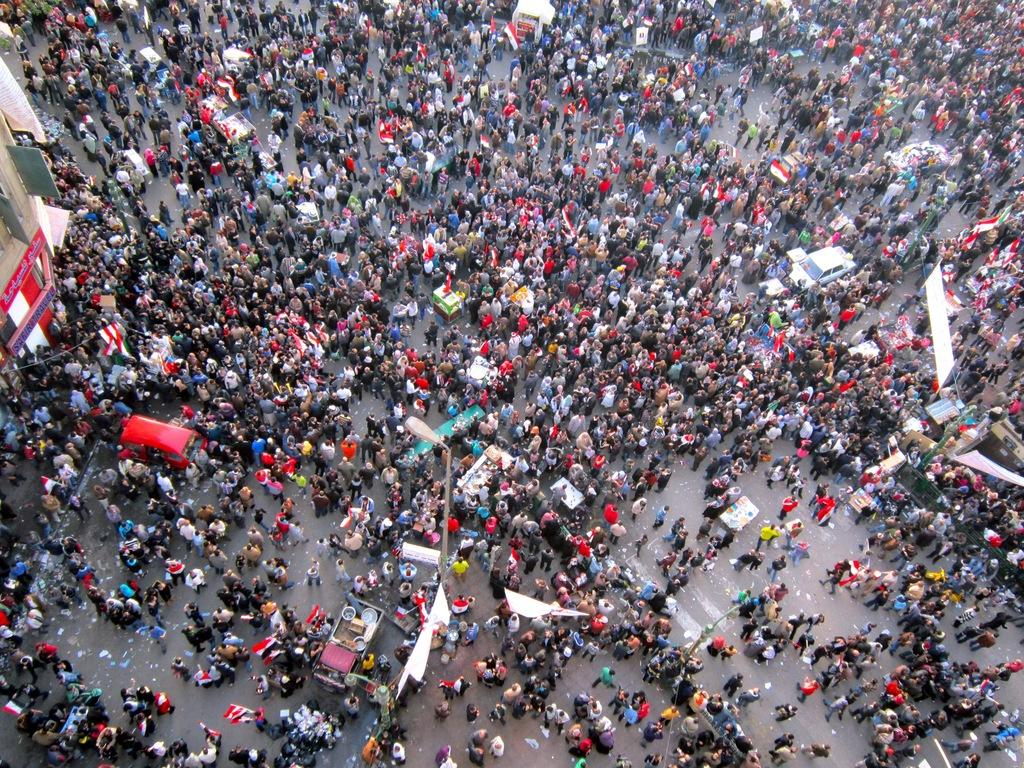What is happening on the road in the image? There is a crowd standing on the road in the image. What else can be seen in the image besides the crowd? Advertisements, motor vehicles, flags on flag posts, littering, and buildings are visible in the image. Can you describe the motor vehicles in the image? Motor vehicles are visible in the image, but their specific types or models cannot be determined from the provided facts. How many flags are present in the image? There are flags on flag posts in the image, but the exact number cannot be determined from the provided facts. What type of zebra can be seen interacting with the crowd in the image? There is no zebra present in the image; it only features a crowd, advertisements, motor vehicles, flags on flag posts, littering, and buildings. 